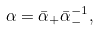<formula> <loc_0><loc_0><loc_500><loc_500>\alpha = \bar { \alpha } _ { + } \bar { \alpha } _ { - } ^ { - 1 } ,</formula> 